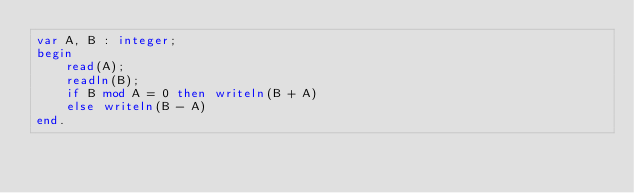Convert code to text. <code><loc_0><loc_0><loc_500><loc_500><_Pascal_>var A, B : integer;
begin
    read(A);
    readln(B);
    if B mod A = 0 then writeln(B + A)
    else writeln(B - A)
end.</code> 